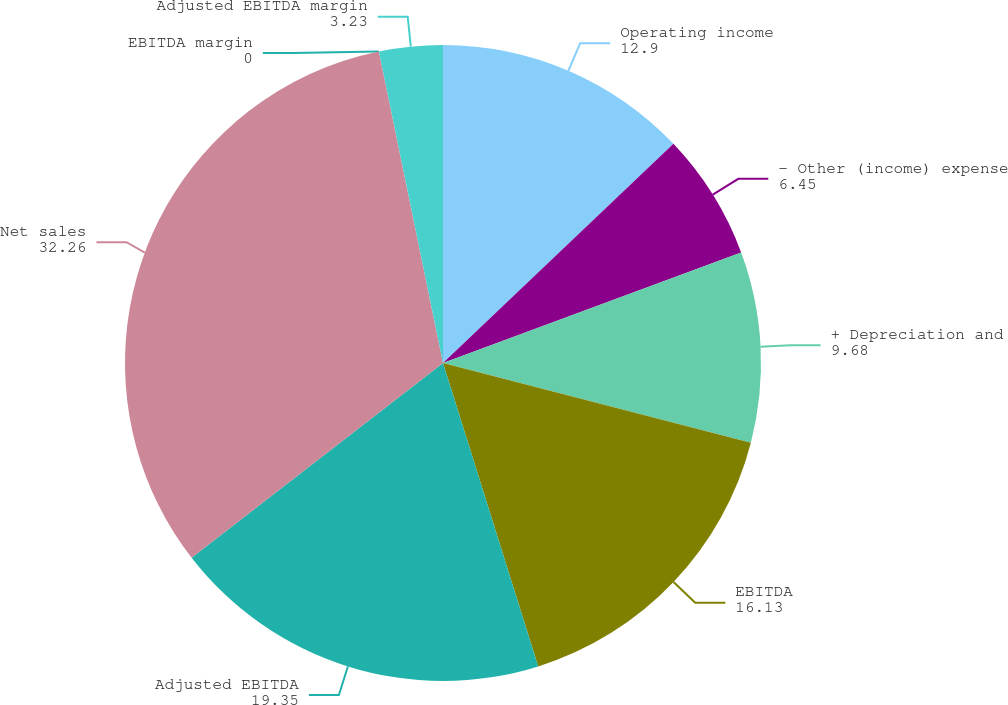Convert chart to OTSL. <chart><loc_0><loc_0><loc_500><loc_500><pie_chart><fcel>Operating income<fcel>- Other (income) expense<fcel>+ Depreciation and<fcel>EBITDA<fcel>Adjusted EBITDA<fcel>Net sales<fcel>EBITDA margin<fcel>Adjusted EBITDA margin<nl><fcel>12.9%<fcel>6.45%<fcel>9.68%<fcel>16.13%<fcel>19.35%<fcel>32.26%<fcel>0.0%<fcel>3.23%<nl></chart> 